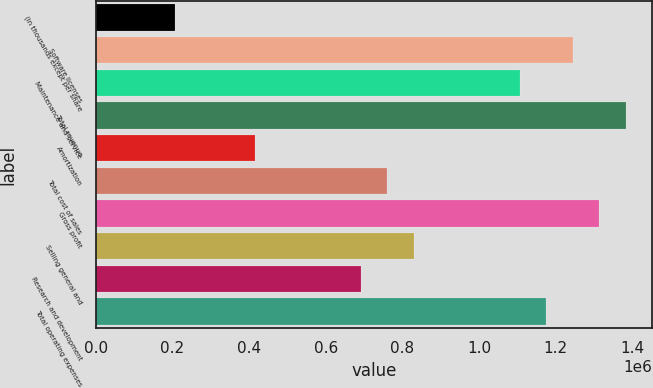<chart> <loc_0><loc_0><loc_500><loc_500><bar_chart><fcel>(in thousands except per share<fcel>Software licenses<fcel>Maintenance and service<fcel>Total revenue<fcel>Amortization<fcel>Total cost of sales<fcel>Gross profit<fcel>Selling general and<fcel>Research and development<fcel>Total operating expenses<nl><fcel>207436<fcel>1.24461e+06<fcel>1.10632e+06<fcel>1.3829e+06<fcel>414870<fcel>760594<fcel>1.31375e+06<fcel>829738<fcel>691449<fcel>1.17546e+06<nl></chart> 